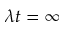Convert formula to latex. <formula><loc_0><loc_0><loc_500><loc_500>\lambda t = \infty</formula> 